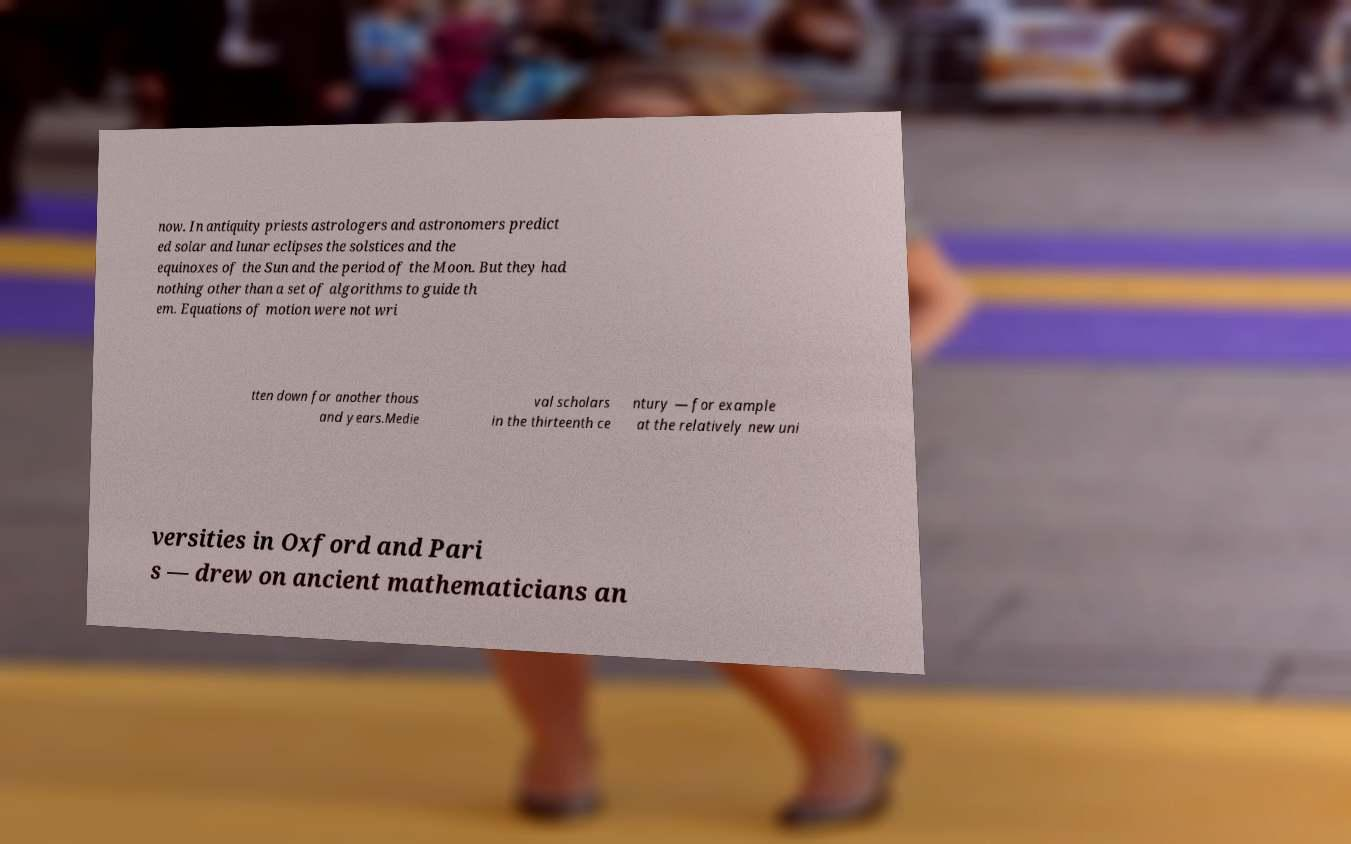There's text embedded in this image that I need extracted. Can you transcribe it verbatim? now. In antiquity priests astrologers and astronomers predict ed solar and lunar eclipses the solstices and the equinoxes of the Sun and the period of the Moon. But they had nothing other than a set of algorithms to guide th em. Equations of motion were not wri tten down for another thous and years.Medie val scholars in the thirteenth ce ntury — for example at the relatively new uni versities in Oxford and Pari s — drew on ancient mathematicians an 